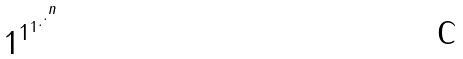Convert formula to latex. <formula><loc_0><loc_0><loc_500><loc_500>1 ^ { 1 ^ { 1 ^ { . ^ { . ^ { n } } } } }</formula> 